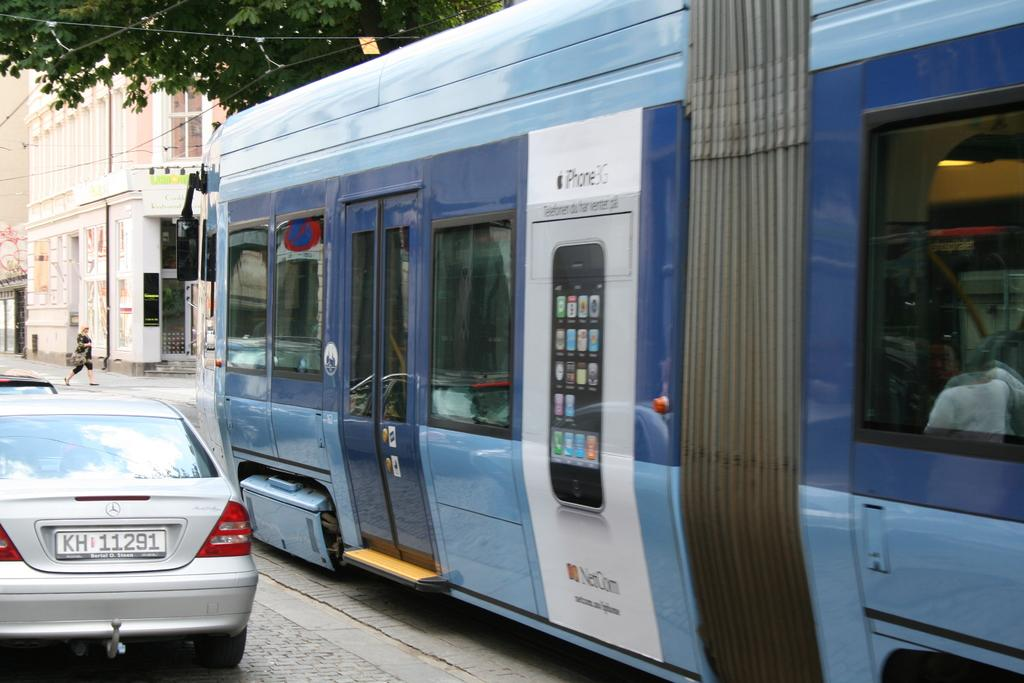What is happening on the road in the image? There are vehicles on a road in the image. What can be seen in the distance behind the vehicles? There is a building in the background of the image. Can you describe the woman's activity in the image? There is a woman walking on a road in the background of the image. What type of vegetation is visible at the top of the image? There is a tree visible at the top of the image. How many cows are grazing on the side of the road in the image? There are no cows present in the image. What is the mass of the tree visible at the top of the image? The mass of the tree cannot be determined from the image alone. --- Facts: 1. There is a person sitting on a bench in the image. 2. The person is reading a book. 3. There is a dog lying next to the person. 4. The bench is located in a park. 5. There are trees in the background of the image. Absurd Topics: parrot, volcano, bicycle Conversation: What is the person in the image doing? The person is sitting on a bench in the image and reading a book. What is the person accompanied by? There is a dog lying next to the person. Where is the bench located? The bench is located in a park. What can be seen in the background of the image? There are trees in the background of the image. Reasoning: Let's think step by step in order to produce the conversation. We start by identifying the main subject in the image, which is the person sitting on the bench. Then, we expand the conversation to include the person's activity (reading a book) and the presence of a dog. We also mention the location of the bench (in a park) and the background (trees). Each question is designed to elicit a specific detail about the image that is known from the provided facts. Absurd Question/Answer: What type of parrot is sitting on the person's shoulder in the image? There is no parrot present in the image. Is there a volcano visible in the background of the image? No, there is no volcano visible in the image; only trees can be seen in the background. 